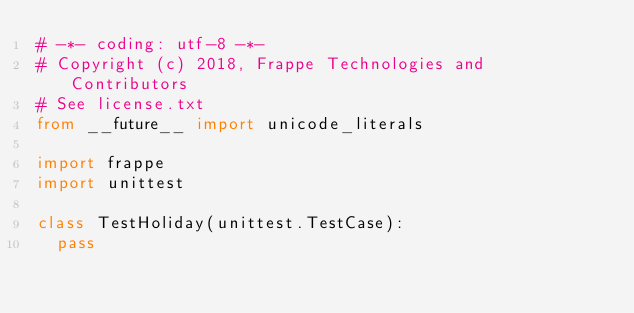<code> <loc_0><loc_0><loc_500><loc_500><_Python_># -*- coding: utf-8 -*-
# Copyright (c) 2018, Frappe Technologies and Contributors
# See license.txt
from __future__ import unicode_literals

import frappe
import unittest

class TestHoliday(unittest.TestCase):
	pass
</code> 